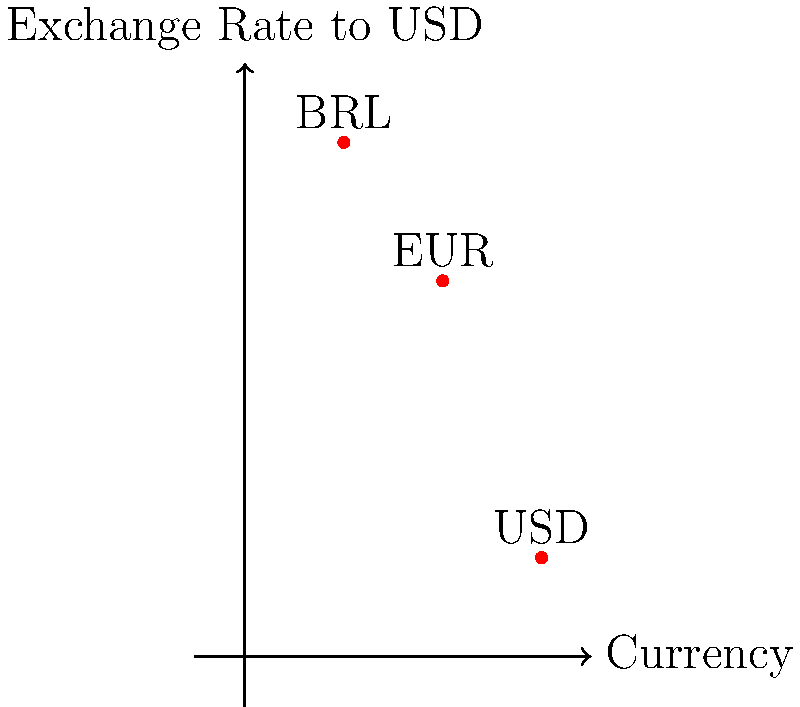As a businessman in Rio de Janeiro, you're analyzing currency exchange rates. The graph shows the exchange rates of Brazilian Real (BRL), Euro (EUR), and US Dollar (USD) relative to USD. If you have 1000 BRL, how many EUR can you get after converting to USD first? Let's approach this step-by-step:

1. First, we need to identify the exchange rates from the graph:
   - 1 USD = 5.2 BRL
   - 1 USD = 3.8 EUR

2. We start with 1000 BRL. Let's convert this to USD:
   $$ \frac{1000 \text{ BRL}}{5.2 \text{ BRL/USD}} = 192.31 \text{ USD} $$

3. Now that we have the amount in USD, we can convert it to EUR:
   $$ 192.31 \text{ USD} \times \frac{3.8 \text{ EUR}}{1 \text{ USD}} = 730.78 \text{ EUR} $$

4. Therefore, 1000 BRL can be converted to approximately 730.78 EUR.

Note: In real-world scenarios, exchange rates fluctuate continuously, and there might be transaction fees involved. This calculation assumes ideal conditions without any fees.
Answer: 730.78 EUR 